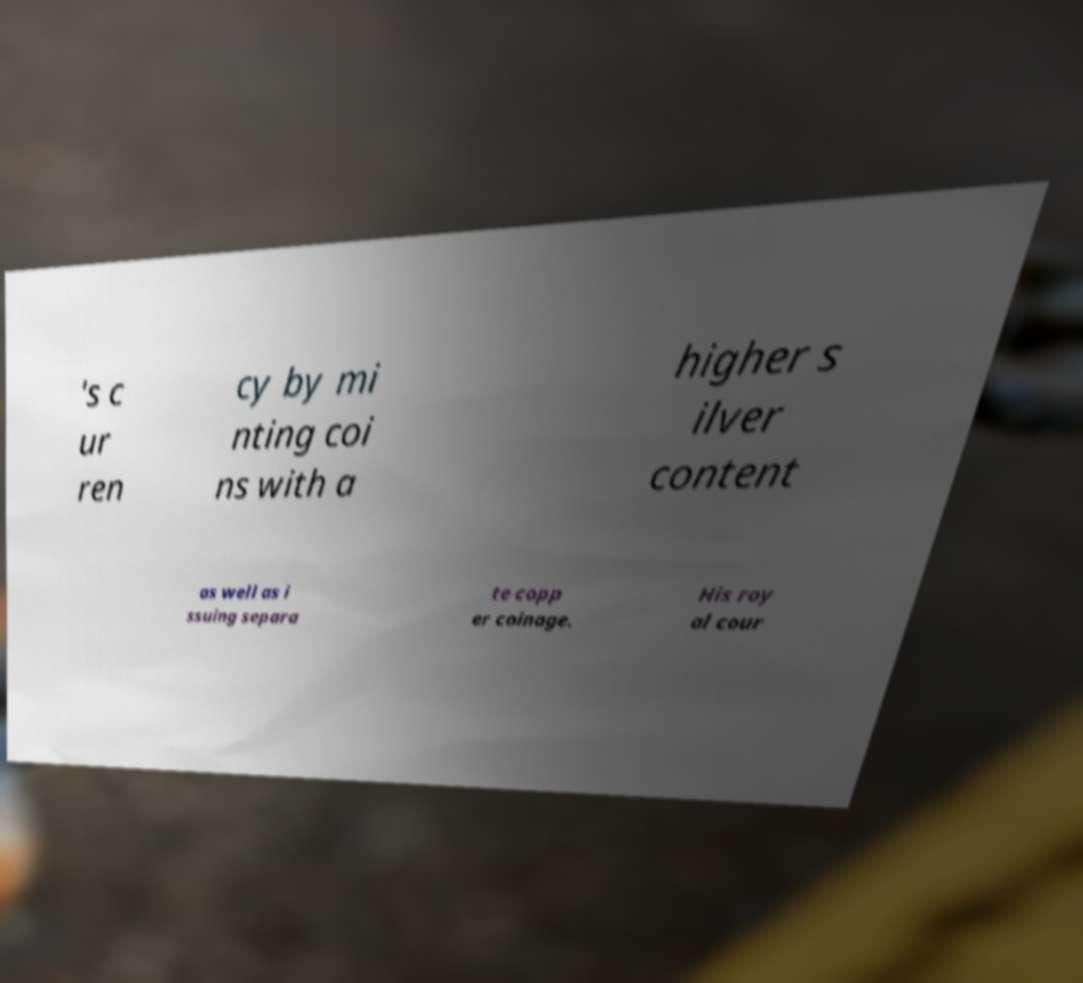Could you assist in decoding the text presented in this image and type it out clearly? 's c ur ren cy by mi nting coi ns with a higher s ilver content as well as i ssuing separa te copp er coinage. His roy al cour 